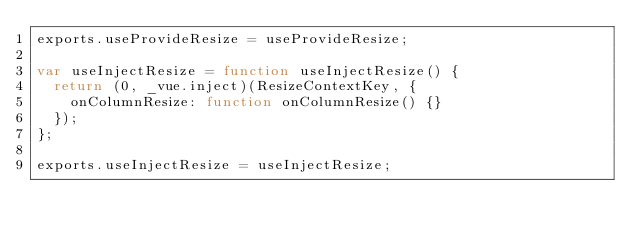<code> <loc_0><loc_0><loc_500><loc_500><_JavaScript_>exports.useProvideResize = useProvideResize;

var useInjectResize = function useInjectResize() {
  return (0, _vue.inject)(ResizeContextKey, {
    onColumnResize: function onColumnResize() {}
  });
};

exports.useInjectResize = useInjectResize;</code> 